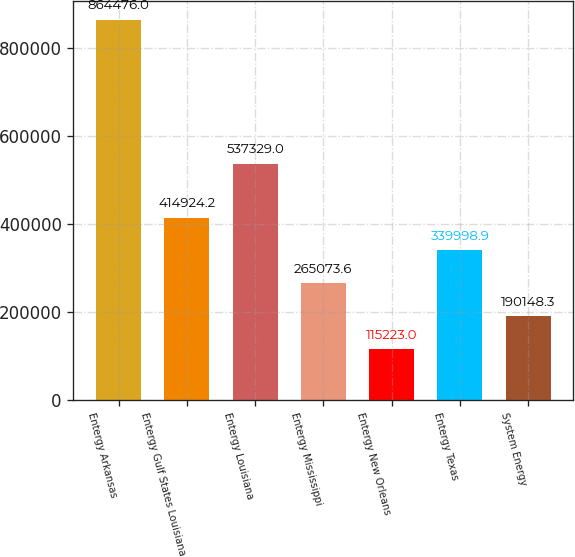Convert chart. <chart><loc_0><loc_0><loc_500><loc_500><bar_chart><fcel>Entergy Arkansas<fcel>Entergy Gulf States Louisiana<fcel>Entergy Louisiana<fcel>Entergy Mississippi<fcel>Entergy New Orleans<fcel>Entergy Texas<fcel>System Energy<nl><fcel>864476<fcel>414924<fcel>537329<fcel>265074<fcel>115223<fcel>339999<fcel>190148<nl></chart> 